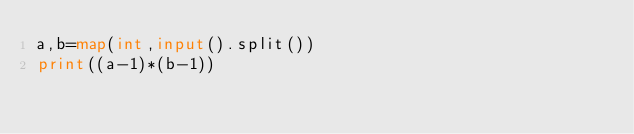Convert code to text. <code><loc_0><loc_0><loc_500><loc_500><_Python_>a,b=map(int,input().split())
print((a-1)*(b-1))</code> 